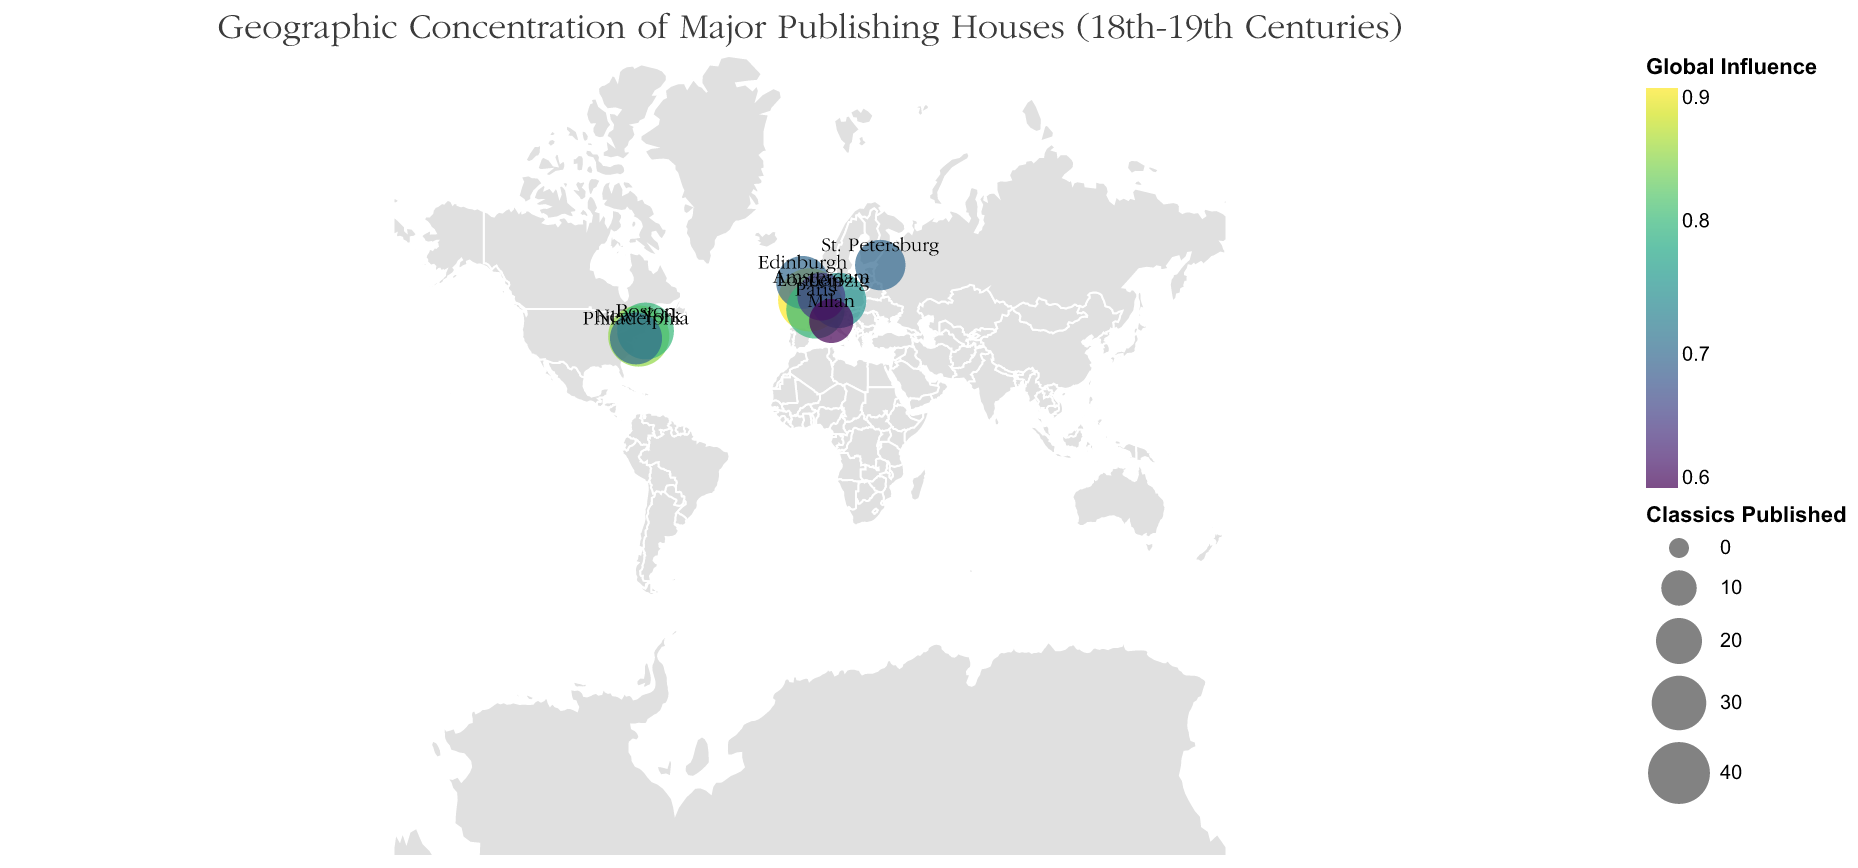How many major publishing houses are represented in the 18th and 19th centuries? Count the number of distinct data points (publishing houses) presented on the map.
Answer: 10 Which publishing house published the most classics and how many did it publish? Identify the publishing house with the largest circle size on the map; the tooltip can provide the exact number.
Answer: John Murray, 42 Which city has the highest global influence? Look for the city marked with the darkest color (highest value on the color scale).
Answer: London Which cities in the USA are represented on the map? Identify and list all cities located within the USA on the map.
Answer: New York, Boston, Philadelphia What is the combined number of classics published by Harper & Brothers and Ticknor and Fields? Sum the number of classics published by each of these two publishing houses (39 + 33).
Answer: 72 Compare the global influence of Hachette Livre in Paris and Brockhaus in Leipzig. Which one has higher global influence? Compare the color shades of the two cities or refer to the tooltip values of Global Influence for Hachette Livre (0.8) and Brockhaus (0.75).
Answer: Hachette Livre Which publishing house was established the earliest and in which year? Identify the publishing house with the earliest "Year Established" from the data provided in tooltips.
Answer: John Murray, 1768 What is the difference in the number of classics published between Elsevier and Mondadori? Subtract the number of classics published by Mondadori from Elsevier (22 - 18).
Answer: 4 Are there any cities on the same latitude but different longitudes? Observe the figure to find any cities that share the same horizontal (latitude) position but differ in vertical (longitude).
Answer: No Which European country has the highest number of major publishing houses? Count and compare the number of cities representing major publishing houses in each European country.
Answer: UK (London and Edinburgh), 2 